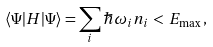<formula> <loc_0><loc_0><loc_500><loc_500>\langle \Psi | H | \Psi \rangle = \sum _ { i } \hbar { \omega } _ { i } n _ { i } \, < \, E _ { \max } \, ,</formula> 